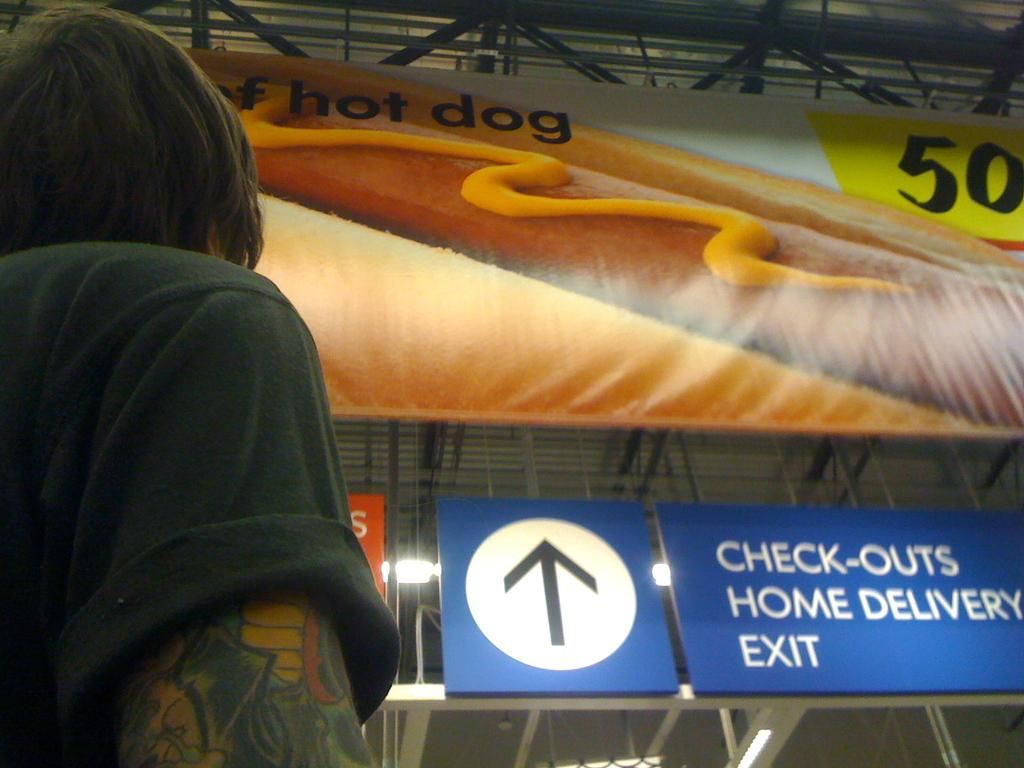What is the main subject in the image? There is a person standing in the image. What type of structure is the image depicting? The image appears to be a hoarding. What materials are used to construct the hoarding? There are boards attached to iron pillars in the image. What type of hands can be seen on the person in the image? There is no information about the person's hands in the image, so we cannot determine their type. What behavior is the person exhibiting in the image? The image only shows the person standing, so we cannot determine their behavior. 